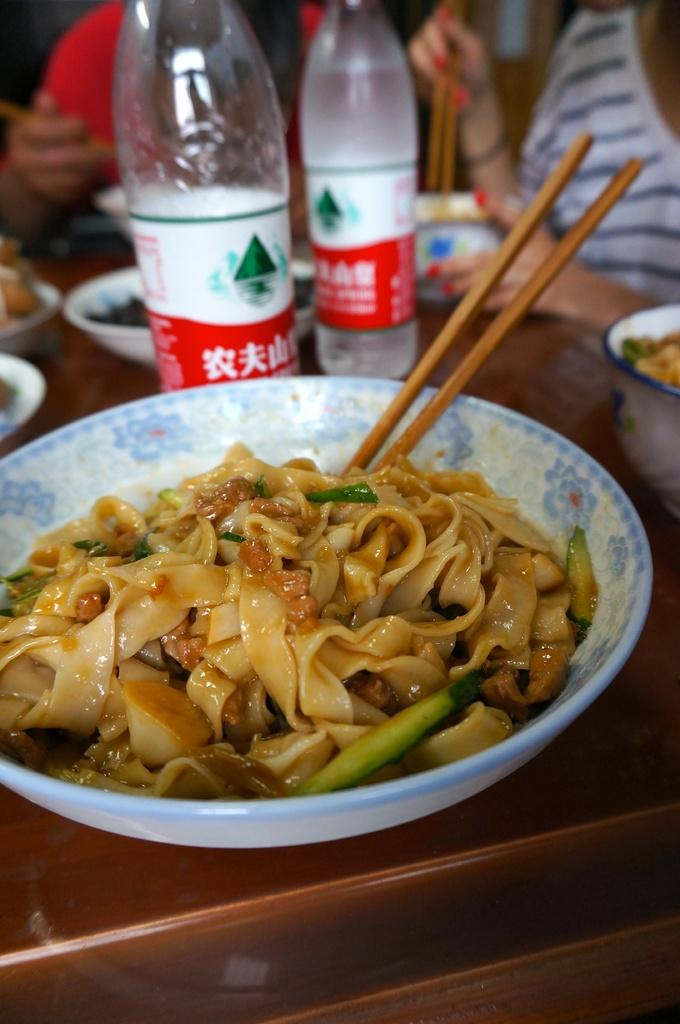What is in the bowl that is visible in the image? There is a bowl of noodles in the image. What utensil is used to eat the noodles in the image? Chopsticks are present in the image. How many bottles are on the table in the image? There are two bottles on the table. How many bowls are on the table in the image? There are some bowls on the table. How many people are sitting beside the table in the image? Two persons are sitting beside the table. What type of feather can be seen on the table in the image? There is no feather present on the table in the image. 